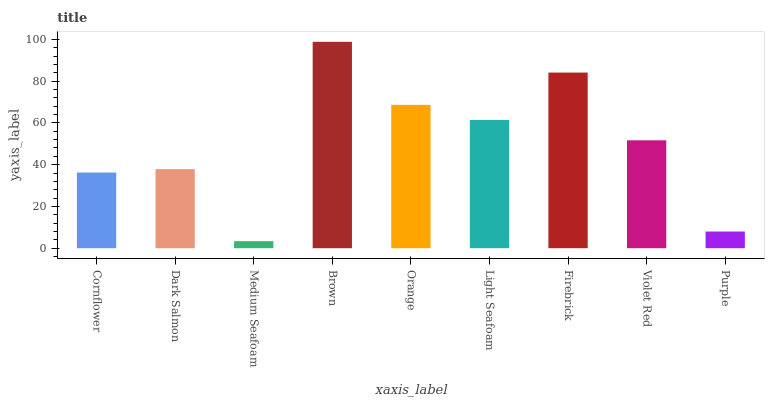Is Medium Seafoam the minimum?
Answer yes or no. Yes. Is Brown the maximum?
Answer yes or no. Yes. Is Dark Salmon the minimum?
Answer yes or no. No. Is Dark Salmon the maximum?
Answer yes or no. No. Is Dark Salmon greater than Cornflower?
Answer yes or no. Yes. Is Cornflower less than Dark Salmon?
Answer yes or no. Yes. Is Cornflower greater than Dark Salmon?
Answer yes or no. No. Is Dark Salmon less than Cornflower?
Answer yes or no. No. Is Violet Red the high median?
Answer yes or no. Yes. Is Violet Red the low median?
Answer yes or no. Yes. Is Light Seafoam the high median?
Answer yes or no. No. Is Medium Seafoam the low median?
Answer yes or no. No. 